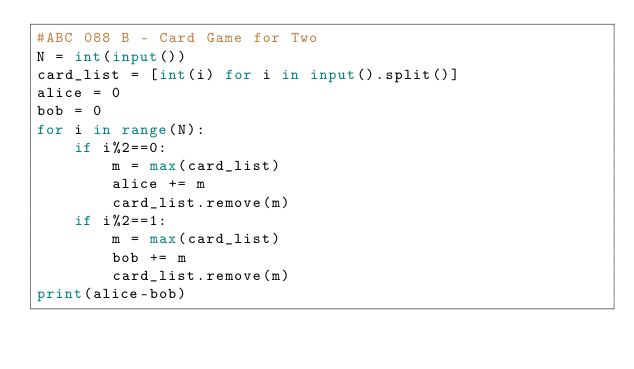Convert code to text. <code><loc_0><loc_0><loc_500><loc_500><_Python_>#ABC 088 B - Card Game for Two
N = int(input())
card_list = [int(i) for i in input().split()]
alice = 0
bob = 0
for i in range(N):
    if i%2==0:
        m = max(card_list)
        alice += m
        card_list.remove(m)
    if i%2==1:
        m = max(card_list)
        bob += m
        card_list.remove(m)
print(alice-bob)</code> 